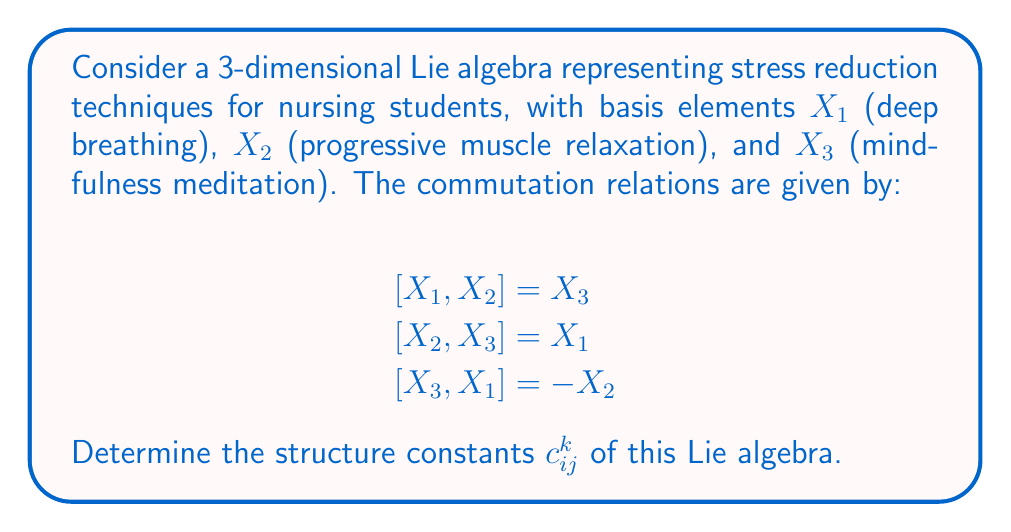Could you help me with this problem? To find the structure constants $c_{ij}^k$ of a Lie algebra, we need to express each commutator in terms of the basis elements:

$$[X_i, X_j] = \sum_{k=1}^3 c_{ij}^k X_k$$

Let's analyze each commutation relation:

1. $[X_1, X_2] = X_3$
   This implies $c_{12}^3 = 1$, and all other $c_{12}^k = 0$

2. $[X_2, X_3] = X_1$
   This implies $c_{23}^1 = 1$, and all other $c_{23}^k = 0$

3. $[X_3, X_1] = -X_2$
   This implies $c_{31}^2 = -1$, and all other $c_{31}^k = 0$

Note that the structure constants are antisymmetric in the lower indices:
$$c_{ij}^k = -c_{ji}^k$$

Therefore, we can deduce:
$c_{21}^3 = -1$
$c_{32}^1 = -1$
$c_{13}^2 = 1$

All other structure constants are zero.
Answer: The non-zero structure constants are:
$$c_{12}^3 = 1, c_{23}^1 = 1, c_{31}^2 = -1$$
$$c_{21}^3 = -1, c_{32}^1 = -1, c_{13}^2 = 1$$
All other $c_{ij}^k = 0$ 